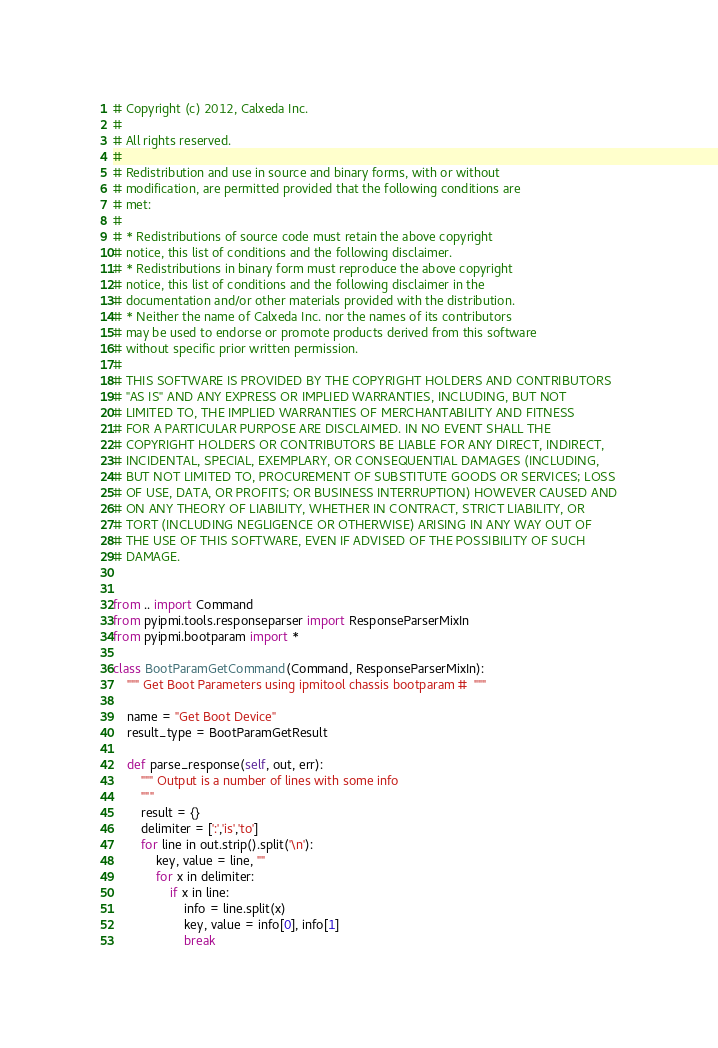Convert code to text. <code><loc_0><loc_0><loc_500><loc_500><_Python_># Copyright (c) 2012, Calxeda Inc.
#
# All rights reserved.
#
# Redistribution and use in source and binary forms, with or without
# modification, are permitted provided that the following conditions are
# met:
#
# * Redistributions of source code must retain the above copyright
# notice, this list of conditions and the following disclaimer.
# * Redistributions in binary form must reproduce the above copyright
# notice, this list of conditions and the following disclaimer in the
# documentation and/or other materials provided with the distribution.
# * Neither the name of Calxeda Inc. nor the names of its contributors
# may be used to endorse or promote products derived from this software
# without specific prior written permission.
#
# THIS SOFTWARE IS PROVIDED BY THE COPYRIGHT HOLDERS AND CONTRIBUTORS
# "AS IS" AND ANY EXPRESS OR IMPLIED WARRANTIES, INCLUDING, BUT NOT
# LIMITED TO, THE IMPLIED WARRANTIES OF MERCHANTABILITY AND FITNESS
# FOR A PARTICULAR PURPOSE ARE DISCLAIMED. IN NO EVENT SHALL THE
# COPYRIGHT HOLDERS OR CONTRIBUTORS BE LIABLE FOR ANY DIRECT, INDIRECT,
# INCIDENTAL, SPECIAL, EXEMPLARY, OR CONSEQUENTIAL DAMAGES (INCLUDING,
# BUT NOT LIMITED TO, PROCUREMENT OF SUBSTITUTE GOODS OR SERVICES; LOSS
# OF USE, DATA, OR PROFITS; OR BUSINESS INTERRUPTION) HOWEVER CAUSED AND
# ON ANY THEORY OF LIABILITY, WHETHER IN CONTRACT, STRICT LIABILITY, OR
# TORT (INCLUDING NEGLIGENCE OR OTHERWISE) ARISING IN ANY WAY OUT OF
# THE USE OF THIS SOFTWARE, EVEN IF ADVISED OF THE POSSIBILITY OF SUCH
# DAMAGE.


from .. import Command
from pyipmi.tools.responseparser import ResponseParserMixIn
from pyipmi.bootparam import *

class BootParamGetCommand(Command, ResponseParserMixIn):
    """ Get Boot Parameters using ipmitool chassis bootparam #  """
    
    name = "Get Boot Device"
    result_type = BootParamGetResult
    
    def parse_response(self, out, err):
        """ Output is a number of lines with some info
        """
        result = {}
        delimiter = [':','is','to']
        for line in out.strip().split('\n'):
            key, value = line, ""
            for x in delimiter:
                if x in line: 
                    info = line.split(x)
                    key, value = info[0], info[1]
                    break             </code> 